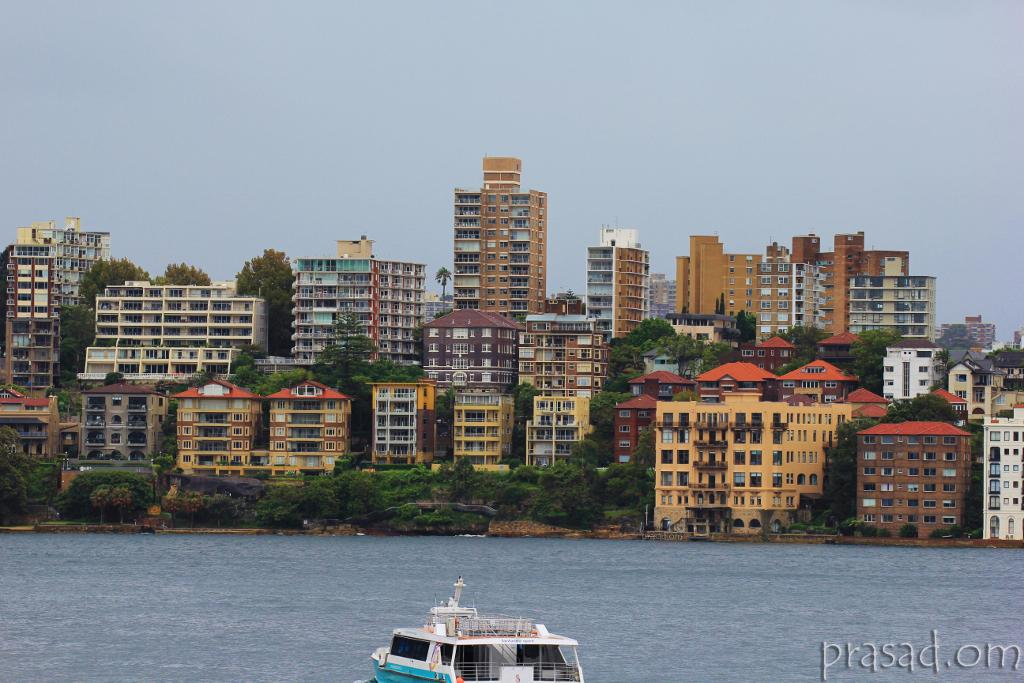What is in the water in the image? There is a boat in the water in the image. What can be seen on the boat? Text is present in the image, which might be on the boat. What type of vegetation is visible in the image? Trees and plants are visible in the image. What type of barrier is present in the image? There is a fence in the image. What type of structures are visible in the image? Buildings are visible in the image. What type of ground cover is present in the image? Grass is present in the image. What type of pathway is visible in the image? There is a road in the image. What type of openings are visible in the image? Windows are visible in the image. What part of the natural environment is visible in the image? The sky is visible in the image. What might be the location of the image? The image may have been taken near a lake. How does the boat help the people in the image sleep better? The image does not show any people or indicate any connection between the boat and sleep. --- Facts: 1. There is a person holding a book in the image. 2. The person is sitting on a chair. 3. The chair is made of wood. 4. The book has a blue cover. 5. There is a table next to the chair. 6. The table has a lamp on it. 7. The lamp has a green shade. 8. The room has a wooden floor. 9. The room has a window. 10. The window has curtains. Absurd Topics: dance, ocean, elephant Conversation: What is the person in the image holding? The person is holding a book in the image. What is the person sitting on? The person is sitting on a chair in the image. What material is the chair made of? The chair is made of wood. What color is the book cover? The book has a blue cover. What is located next to the chair? There is a table next to the chair in the image. What is on the table? The table has a lamp on it. What color is the lamp shade? The lamp has a green shade. What type of flooring is in the room? The room has a wooden floor. What type of window is in the room? The room has a window. What type of window treatment is in the room? The window has curtains. Reasoning: Let's think step by step in order to produce the conversation. We start by identifying the main subject in the image, which is the person holding a book. Then, we expand the conversation to include other items that are also visible, such as the chair, table, lamp, flooring, window, 